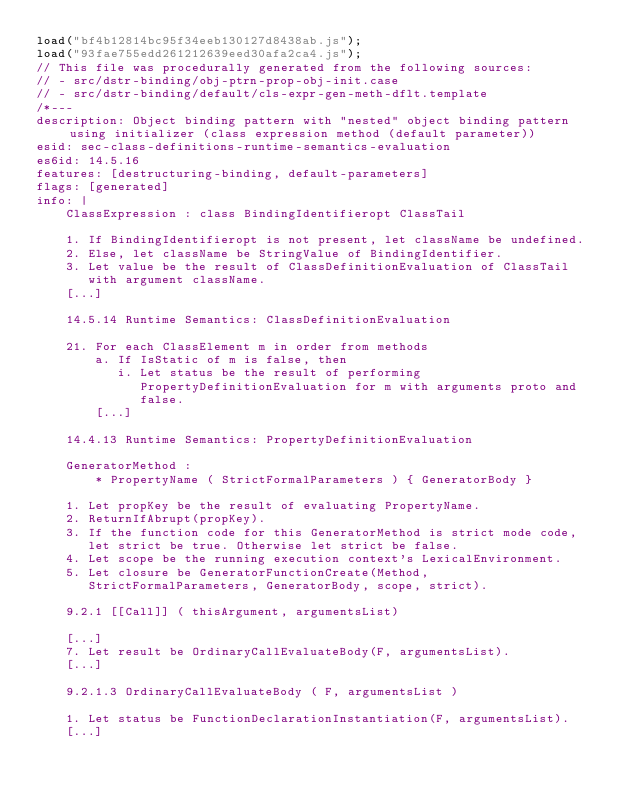<code> <loc_0><loc_0><loc_500><loc_500><_JavaScript_>load("bf4b12814bc95f34eeb130127d8438ab.js");
load("93fae755edd261212639eed30afa2ca4.js");
// This file was procedurally generated from the following sources:
// - src/dstr-binding/obj-ptrn-prop-obj-init.case
// - src/dstr-binding/default/cls-expr-gen-meth-dflt.template
/*---
description: Object binding pattern with "nested" object binding pattern using initializer (class expression method (default parameter))
esid: sec-class-definitions-runtime-semantics-evaluation
es6id: 14.5.16
features: [destructuring-binding, default-parameters]
flags: [generated]
info: |
    ClassExpression : class BindingIdentifieropt ClassTail

    1. If BindingIdentifieropt is not present, let className be undefined.
    2. Else, let className be StringValue of BindingIdentifier.
    3. Let value be the result of ClassDefinitionEvaluation of ClassTail
       with argument className.
    [...]

    14.5.14 Runtime Semantics: ClassDefinitionEvaluation

    21. For each ClassElement m in order from methods
        a. If IsStatic of m is false, then
           i. Let status be the result of performing
              PropertyDefinitionEvaluation for m with arguments proto and
              false.
        [...]

    14.4.13 Runtime Semantics: PropertyDefinitionEvaluation

    GeneratorMethod :
        * PropertyName ( StrictFormalParameters ) { GeneratorBody }

    1. Let propKey be the result of evaluating PropertyName.
    2. ReturnIfAbrupt(propKey).
    3. If the function code for this GeneratorMethod is strict mode code,
       let strict be true. Otherwise let strict be false.
    4. Let scope be the running execution context's LexicalEnvironment.
    5. Let closure be GeneratorFunctionCreate(Method,
       StrictFormalParameters, GeneratorBody, scope, strict).

    9.2.1 [[Call]] ( thisArgument, argumentsList)

    [...]
    7. Let result be OrdinaryCallEvaluateBody(F, argumentsList).
    [...]

    9.2.1.3 OrdinaryCallEvaluateBody ( F, argumentsList )

    1. Let status be FunctionDeclarationInstantiation(F, argumentsList).
    [...]
</code> 